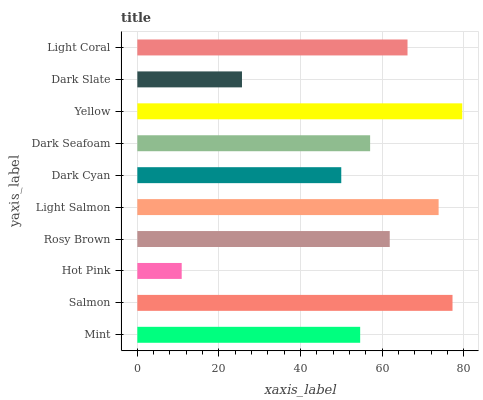Is Hot Pink the minimum?
Answer yes or no. Yes. Is Yellow the maximum?
Answer yes or no. Yes. Is Salmon the minimum?
Answer yes or no. No. Is Salmon the maximum?
Answer yes or no. No. Is Salmon greater than Mint?
Answer yes or no. Yes. Is Mint less than Salmon?
Answer yes or no. Yes. Is Mint greater than Salmon?
Answer yes or no. No. Is Salmon less than Mint?
Answer yes or no. No. Is Rosy Brown the high median?
Answer yes or no. Yes. Is Dark Seafoam the low median?
Answer yes or no. Yes. Is Dark Cyan the high median?
Answer yes or no. No. Is Rosy Brown the low median?
Answer yes or no. No. 